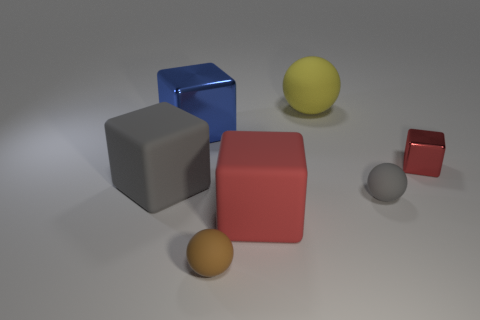What time of day do you think it is based on the lighting in the image? The lighting in the image appears artificial, likely from indoor lighting, so it doesn't give a clear indication of the time of day. 